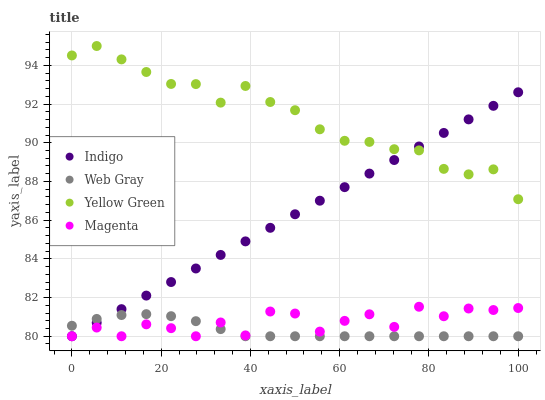Does Web Gray have the minimum area under the curve?
Answer yes or no. Yes. Does Yellow Green have the maximum area under the curve?
Answer yes or no. Yes. Does Indigo have the minimum area under the curve?
Answer yes or no. No. Does Indigo have the maximum area under the curve?
Answer yes or no. No. Is Indigo the smoothest?
Answer yes or no. Yes. Is Magenta the roughest?
Answer yes or no. Yes. Is Web Gray the smoothest?
Answer yes or no. No. Is Web Gray the roughest?
Answer yes or no. No. Does Magenta have the lowest value?
Answer yes or no. Yes. Does Yellow Green have the lowest value?
Answer yes or no. No. Does Yellow Green have the highest value?
Answer yes or no. Yes. Does Indigo have the highest value?
Answer yes or no. No. Is Web Gray less than Yellow Green?
Answer yes or no. Yes. Is Yellow Green greater than Web Gray?
Answer yes or no. Yes. Does Indigo intersect Yellow Green?
Answer yes or no. Yes. Is Indigo less than Yellow Green?
Answer yes or no. No. Is Indigo greater than Yellow Green?
Answer yes or no. No. Does Web Gray intersect Yellow Green?
Answer yes or no. No. 